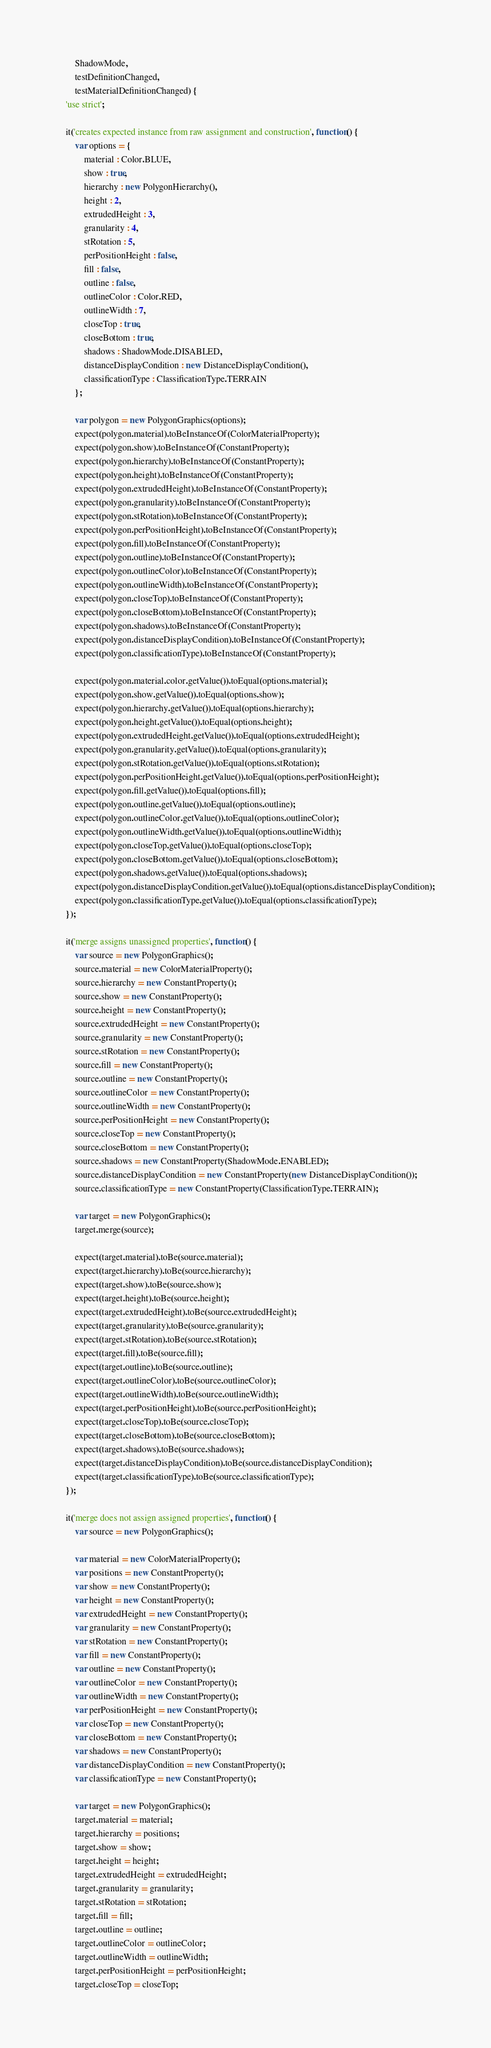<code> <loc_0><loc_0><loc_500><loc_500><_JavaScript_>        ShadowMode,
        testDefinitionChanged,
        testMaterialDefinitionChanged) {
    'use strict';

    it('creates expected instance from raw assignment and construction', function() {
        var options = {
            material : Color.BLUE,
            show : true,
            hierarchy : new PolygonHierarchy(),
            height : 2,
            extrudedHeight : 3,
            granularity : 4,
            stRotation : 5,
            perPositionHeight : false,
            fill : false,
            outline : false,
            outlineColor : Color.RED,
            outlineWidth : 7,
            closeTop : true,
            closeBottom : true,
            shadows : ShadowMode.DISABLED,
            distanceDisplayCondition : new DistanceDisplayCondition(),
            classificationType : ClassificationType.TERRAIN
        };

        var polygon = new PolygonGraphics(options);
        expect(polygon.material).toBeInstanceOf(ColorMaterialProperty);
        expect(polygon.show).toBeInstanceOf(ConstantProperty);
        expect(polygon.hierarchy).toBeInstanceOf(ConstantProperty);
        expect(polygon.height).toBeInstanceOf(ConstantProperty);
        expect(polygon.extrudedHeight).toBeInstanceOf(ConstantProperty);
        expect(polygon.granularity).toBeInstanceOf(ConstantProperty);
        expect(polygon.stRotation).toBeInstanceOf(ConstantProperty);
        expect(polygon.perPositionHeight).toBeInstanceOf(ConstantProperty);
        expect(polygon.fill).toBeInstanceOf(ConstantProperty);
        expect(polygon.outline).toBeInstanceOf(ConstantProperty);
        expect(polygon.outlineColor).toBeInstanceOf(ConstantProperty);
        expect(polygon.outlineWidth).toBeInstanceOf(ConstantProperty);
        expect(polygon.closeTop).toBeInstanceOf(ConstantProperty);
        expect(polygon.closeBottom).toBeInstanceOf(ConstantProperty);
        expect(polygon.shadows).toBeInstanceOf(ConstantProperty);
        expect(polygon.distanceDisplayCondition).toBeInstanceOf(ConstantProperty);
        expect(polygon.classificationType).toBeInstanceOf(ConstantProperty);

        expect(polygon.material.color.getValue()).toEqual(options.material);
        expect(polygon.show.getValue()).toEqual(options.show);
        expect(polygon.hierarchy.getValue()).toEqual(options.hierarchy);
        expect(polygon.height.getValue()).toEqual(options.height);
        expect(polygon.extrudedHeight.getValue()).toEqual(options.extrudedHeight);
        expect(polygon.granularity.getValue()).toEqual(options.granularity);
        expect(polygon.stRotation.getValue()).toEqual(options.stRotation);
        expect(polygon.perPositionHeight.getValue()).toEqual(options.perPositionHeight);
        expect(polygon.fill.getValue()).toEqual(options.fill);
        expect(polygon.outline.getValue()).toEqual(options.outline);
        expect(polygon.outlineColor.getValue()).toEqual(options.outlineColor);
        expect(polygon.outlineWidth.getValue()).toEqual(options.outlineWidth);
        expect(polygon.closeTop.getValue()).toEqual(options.closeTop);
        expect(polygon.closeBottom.getValue()).toEqual(options.closeBottom);
        expect(polygon.shadows.getValue()).toEqual(options.shadows);
        expect(polygon.distanceDisplayCondition.getValue()).toEqual(options.distanceDisplayCondition);
        expect(polygon.classificationType.getValue()).toEqual(options.classificationType);
    });

    it('merge assigns unassigned properties', function() {
        var source = new PolygonGraphics();
        source.material = new ColorMaterialProperty();
        source.hierarchy = new ConstantProperty();
        source.show = new ConstantProperty();
        source.height = new ConstantProperty();
        source.extrudedHeight = new ConstantProperty();
        source.granularity = new ConstantProperty();
        source.stRotation = new ConstantProperty();
        source.fill = new ConstantProperty();
        source.outline = new ConstantProperty();
        source.outlineColor = new ConstantProperty();
        source.outlineWidth = new ConstantProperty();
        source.perPositionHeight = new ConstantProperty();
        source.closeTop = new ConstantProperty();
        source.closeBottom = new ConstantProperty();
        source.shadows = new ConstantProperty(ShadowMode.ENABLED);
        source.distanceDisplayCondition = new ConstantProperty(new DistanceDisplayCondition());
        source.classificationType = new ConstantProperty(ClassificationType.TERRAIN);

        var target = new PolygonGraphics();
        target.merge(source);

        expect(target.material).toBe(source.material);
        expect(target.hierarchy).toBe(source.hierarchy);
        expect(target.show).toBe(source.show);
        expect(target.height).toBe(source.height);
        expect(target.extrudedHeight).toBe(source.extrudedHeight);
        expect(target.granularity).toBe(source.granularity);
        expect(target.stRotation).toBe(source.stRotation);
        expect(target.fill).toBe(source.fill);
        expect(target.outline).toBe(source.outline);
        expect(target.outlineColor).toBe(source.outlineColor);
        expect(target.outlineWidth).toBe(source.outlineWidth);
        expect(target.perPositionHeight).toBe(source.perPositionHeight);
        expect(target.closeTop).toBe(source.closeTop);
        expect(target.closeBottom).toBe(source.closeBottom);
        expect(target.shadows).toBe(source.shadows);
        expect(target.distanceDisplayCondition).toBe(source.distanceDisplayCondition);
        expect(target.classificationType).toBe(source.classificationType);
    });

    it('merge does not assign assigned properties', function() {
        var source = new PolygonGraphics();

        var material = new ColorMaterialProperty();
        var positions = new ConstantProperty();
        var show = new ConstantProperty();
        var height = new ConstantProperty();
        var extrudedHeight = new ConstantProperty();
        var granularity = new ConstantProperty();
        var stRotation = new ConstantProperty();
        var fill = new ConstantProperty();
        var outline = new ConstantProperty();
        var outlineColor = new ConstantProperty();
        var outlineWidth = new ConstantProperty();
        var perPositionHeight = new ConstantProperty();
        var closeTop = new ConstantProperty();
        var closeBottom = new ConstantProperty();
        var shadows = new ConstantProperty();
        var distanceDisplayCondition = new ConstantProperty();
        var classificationType = new ConstantProperty();

        var target = new PolygonGraphics();
        target.material = material;
        target.hierarchy = positions;
        target.show = show;
        target.height = height;
        target.extrudedHeight = extrudedHeight;
        target.granularity = granularity;
        target.stRotation = stRotation;
        target.fill = fill;
        target.outline = outline;
        target.outlineColor = outlineColor;
        target.outlineWidth = outlineWidth;
        target.perPositionHeight = perPositionHeight;
        target.closeTop = closeTop;</code> 